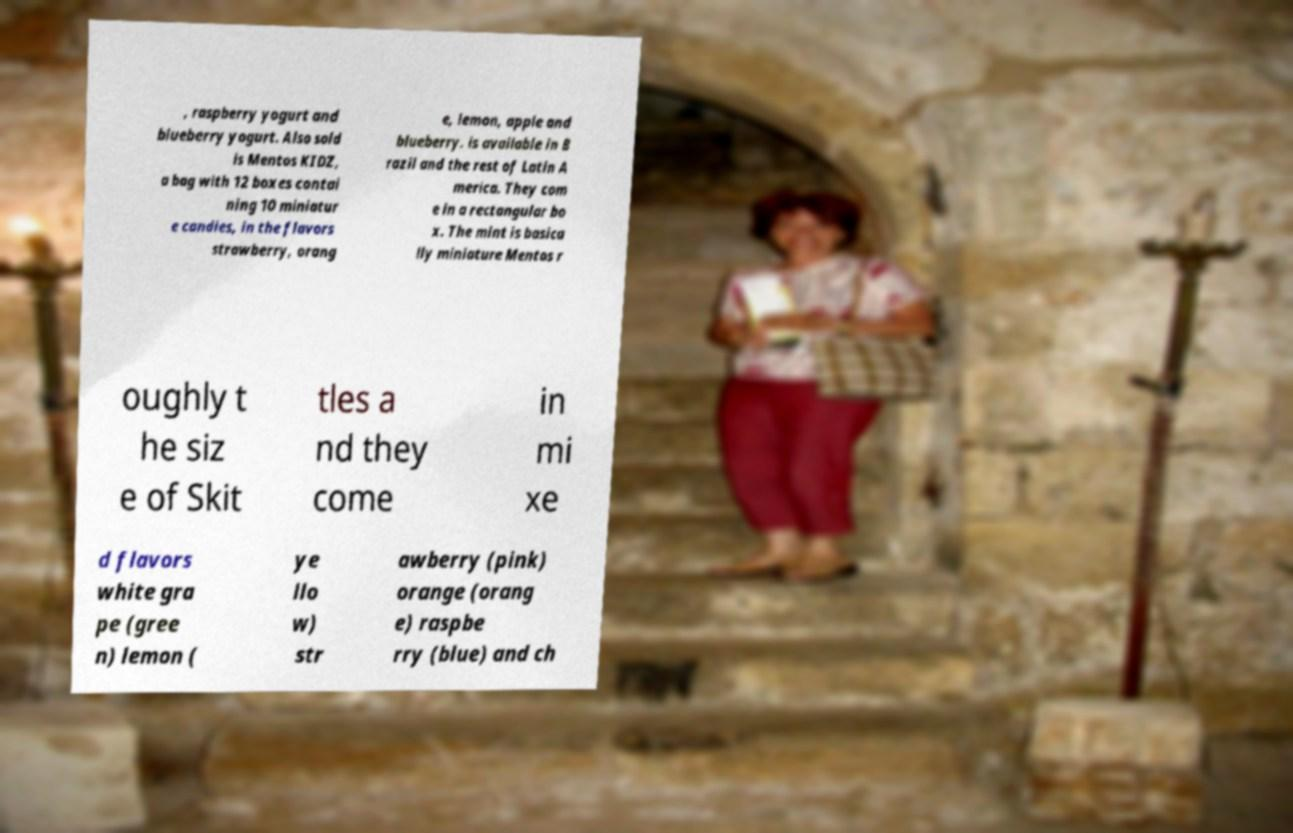There's text embedded in this image that I need extracted. Can you transcribe it verbatim? , raspberry yogurt and blueberry yogurt. Also sold is Mentos KIDZ, a bag with 12 boxes contai ning 10 miniatur e candies, in the flavors strawberry, orang e, lemon, apple and blueberry. is available in B razil and the rest of Latin A merica. They com e in a rectangular bo x. The mint is basica lly miniature Mentos r oughly t he siz e of Skit tles a nd they come in mi xe d flavors white gra pe (gree n) lemon ( ye llo w) str awberry (pink) orange (orang e) raspbe rry (blue) and ch 